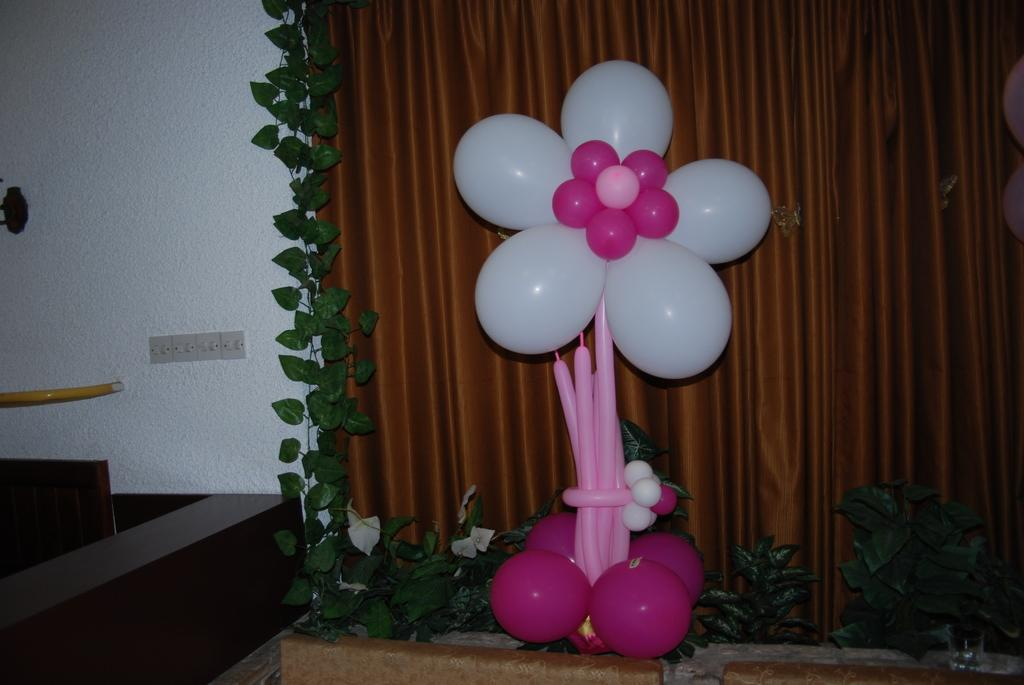Where was the image taken? The image was taken in a room. What can be seen in the center of the picture? There are balloons, plants, and a curtain in the center of the picture. What color is the wall on the left side of the picture? The wall on the left side of the picture is painted in red. What other objects can be seen on the left side of the picture? There is a pipe and a plug board on the left side of the picture. Where can the lettuce be found in the image? There is no lettuce present in the image. What type of faucet is visible in the image? There is no faucet present in the image. 